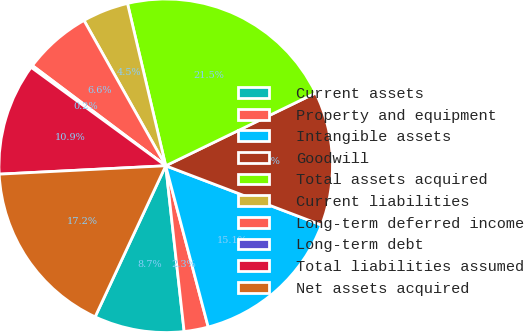Convert chart. <chart><loc_0><loc_0><loc_500><loc_500><pie_chart><fcel>Current assets<fcel>Property and equipment<fcel>Intangible assets<fcel>Goodwill<fcel>Total assets acquired<fcel>Current liabilities<fcel>Long-term deferred income<fcel>Long-term debt<fcel>Total liabilities assumed<fcel>Net assets acquired<nl><fcel>8.72%<fcel>2.34%<fcel>15.11%<fcel>12.98%<fcel>21.49%<fcel>4.47%<fcel>6.59%<fcel>0.21%<fcel>10.85%<fcel>17.24%<nl></chart> 